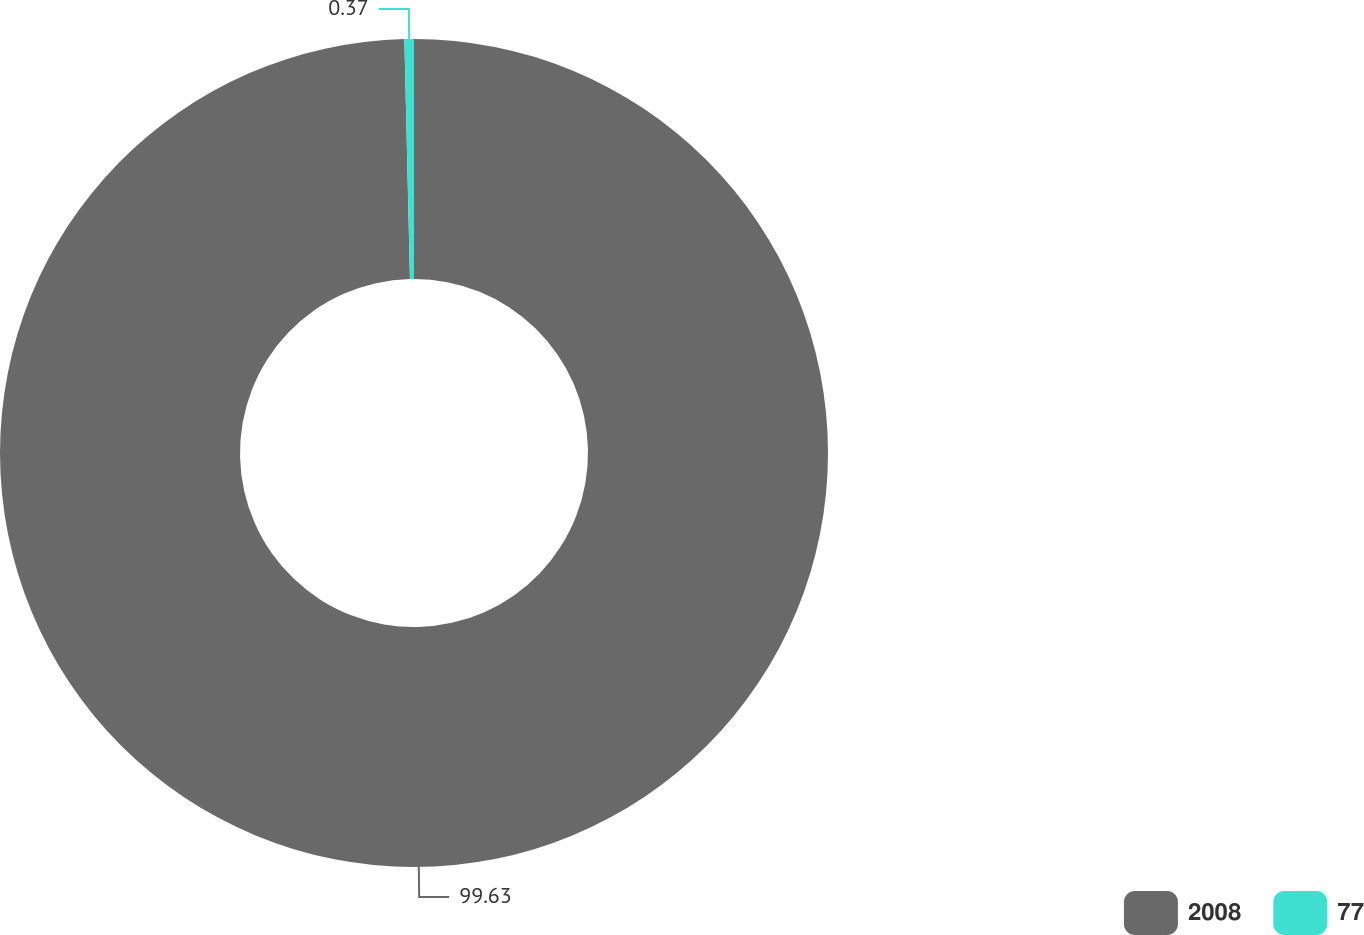<chart> <loc_0><loc_0><loc_500><loc_500><pie_chart><fcel>2008<fcel>77<nl><fcel>99.63%<fcel>0.37%<nl></chart> 